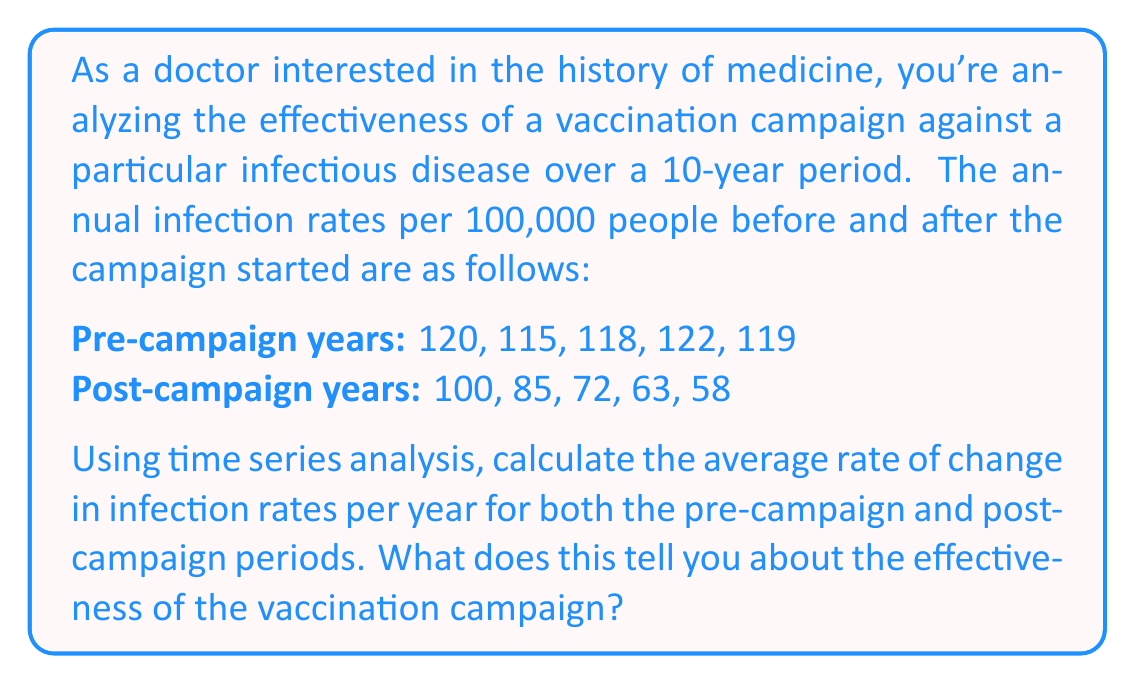What is the answer to this math problem? To evaluate the effectiveness of the vaccination campaign, we'll calculate and compare the average rate of change in infection rates for both pre-campaign and post-campaign periods.

1. Pre-campaign period:

Let's use the linear regression formula to find the slope, which represents the average rate of change:

$$m = \frac{n\sum xy - \sum x \sum y}{n\sum x^2 - (\sum x)^2}$$

Where:
$n$ = number of years (5)
$x$ = year number (1, 2, 3, 4, 5)
$y$ = infection rate

$$\sum x = 1 + 2 + 3 + 4 + 5 = 15$$
$$\sum y = 120 + 115 + 118 + 122 + 119 = 594$$
$$\sum xy = 1(120) + 2(115) + 3(118) + 4(122) + 5(119) = 1785$$
$$\sum x^2 = 1^2 + 2^2 + 3^2 + 4^2 + 5^2 = 55$$

Substituting these values:

$$m = \frac{5(1785) - 15(594)}{5(55) - 15^2} = \frac{8925 - 8910}{275 - 225} = \frac{15}{50} = 0.3$$

The average rate of change for the pre-campaign period is 0.3 infections per 100,000 people per year.

2. Post-campaign period:

Using the same method:

$$\sum x = 15$$
$$\sum y = 100 + 85 + 72 + 63 + 58 = 378$$
$$\sum xy = 1(100) + 2(85) + 3(72) + 4(63) + 5(58) = 1134$$
$$\sum x^2 = 55$$

$$m = \frac{5(1134) - 15(378)}{5(55) - 15^2} = \frac{5670 - 5670}{275 - 225} = \frac{-960}{50} = -19.2$$

The average rate of change for the post-campaign period is -19.2 infections per 100,000 people per year.

Comparing these results:
- Pre-campaign: +0.3 infections per 100,000 per year (slight increase)
- Post-campaign: -19.2 infections per 100,000 per year (significant decrease)

This analysis suggests that the vaccination campaign was highly effective in reducing infection rates. The pre-campaign period showed a slight upward trend in infections, while the post-campaign period demonstrated a substantial downward trend, with an average decrease of 19.2 infections per 100,000 people each year.
Answer: The average rate of change in infection rates:
Pre-campaign: +0.3 infections per 100,000 people per year
Post-campaign: -19.2 infections per 100,000 people per year

This indicates that the vaccination campaign was highly effective, transforming a slightly increasing trend into a significant decreasing trend in infection rates. 